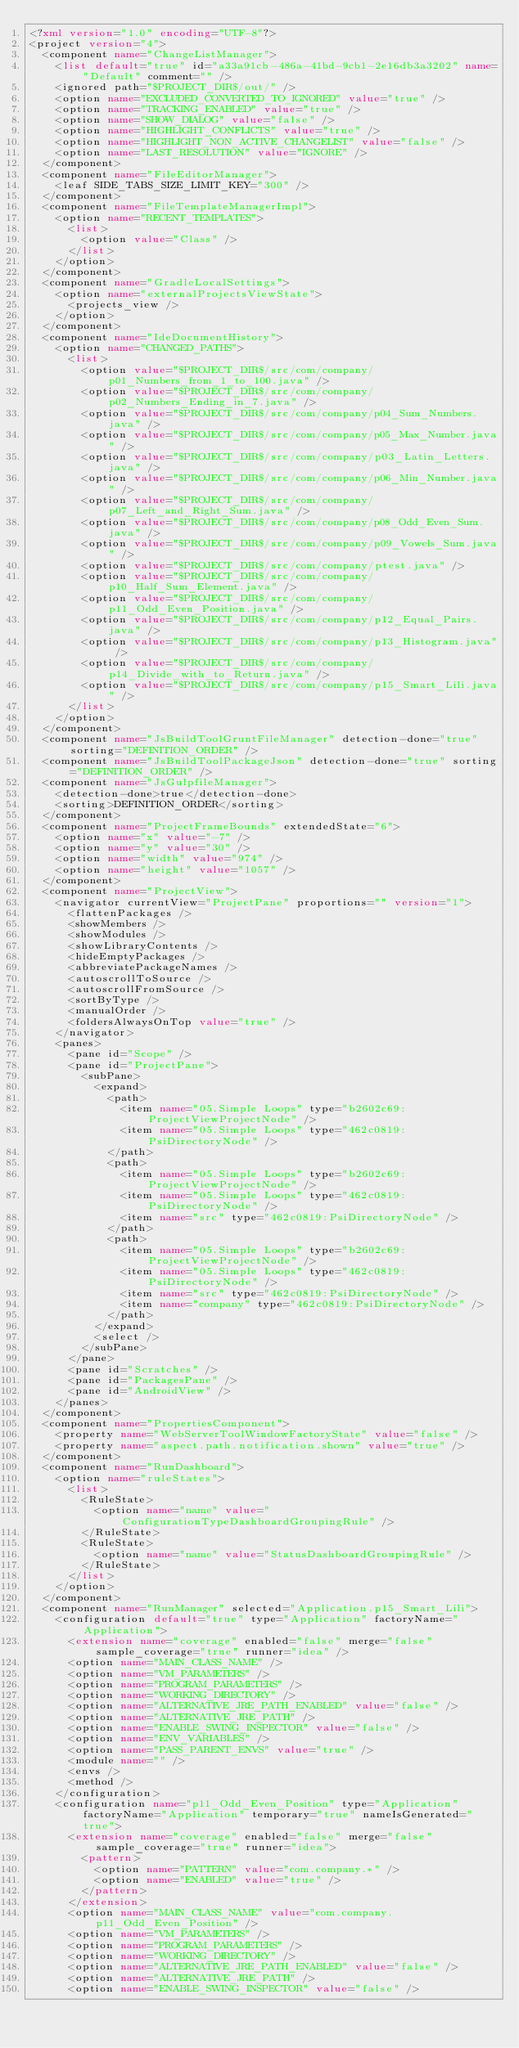<code> <loc_0><loc_0><loc_500><loc_500><_XML_><?xml version="1.0" encoding="UTF-8"?>
<project version="4">
  <component name="ChangeListManager">
    <list default="true" id="a33a91cb-486a-41bd-9cb1-2e16db3a3202" name="Default" comment="" />
    <ignored path="$PROJECT_DIR$/out/" />
    <option name="EXCLUDED_CONVERTED_TO_IGNORED" value="true" />
    <option name="TRACKING_ENABLED" value="true" />
    <option name="SHOW_DIALOG" value="false" />
    <option name="HIGHLIGHT_CONFLICTS" value="true" />
    <option name="HIGHLIGHT_NON_ACTIVE_CHANGELIST" value="false" />
    <option name="LAST_RESOLUTION" value="IGNORE" />
  </component>
  <component name="FileEditorManager">
    <leaf SIDE_TABS_SIZE_LIMIT_KEY="300" />
  </component>
  <component name="FileTemplateManagerImpl">
    <option name="RECENT_TEMPLATES">
      <list>
        <option value="Class" />
      </list>
    </option>
  </component>
  <component name="GradleLocalSettings">
    <option name="externalProjectsViewState">
      <projects_view />
    </option>
  </component>
  <component name="IdeDocumentHistory">
    <option name="CHANGED_PATHS">
      <list>
        <option value="$PROJECT_DIR$/src/com/company/p01_Numbers_from_1_to_100.java" />
        <option value="$PROJECT_DIR$/src/com/company/p02_Numbers_Ending_in_7.java" />
        <option value="$PROJECT_DIR$/src/com/company/p04_Sum_Numbers.java" />
        <option value="$PROJECT_DIR$/src/com/company/p05_Max_Number.java" />
        <option value="$PROJECT_DIR$/src/com/company/p03_Latin_Letters.java" />
        <option value="$PROJECT_DIR$/src/com/company/p06_Min_Number.java" />
        <option value="$PROJECT_DIR$/src/com/company/p07_Left_and_Right_Sum.java" />
        <option value="$PROJECT_DIR$/src/com/company/p08_Odd_Even_Sum.java" />
        <option value="$PROJECT_DIR$/src/com/company/p09_Vowels_Sum.java" />
        <option value="$PROJECT_DIR$/src/com/company/ptest.java" />
        <option value="$PROJECT_DIR$/src/com/company/p10_Half_Sum_Element.java" />
        <option value="$PROJECT_DIR$/src/com/company/p11_Odd_Even_Position.java" />
        <option value="$PROJECT_DIR$/src/com/company/p12_Equal_Pairs.java" />
        <option value="$PROJECT_DIR$/src/com/company/p13_Histogram.java" />
        <option value="$PROJECT_DIR$/src/com/company/p14_Divide_with_to_Return.java" />
        <option value="$PROJECT_DIR$/src/com/company/p15_Smart_Lili.java" />
      </list>
    </option>
  </component>
  <component name="JsBuildToolGruntFileManager" detection-done="true" sorting="DEFINITION_ORDER" />
  <component name="JsBuildToolPackageJson" detection-done="true" sorting="DEFINITION_ORDER" />
  <component name="JsGulpfileManager">
    <detection-done>true</detection-done>
    <sorting>DEFINITION_ORDER</sorting>
  </component>
  <component name="ProjectFrameBounds" extendedState="6">
    <option name="x" value="-7" />
    <option name="y" value="30" />
    <option name="width" value="974" />
    <option name="height" value="1057" />
  </component>
  <component name="ProjectView">
    <navigator currentView="ProjectPane" proportions="" version="1">
      <flattenPackages />
      <showMembers />
      <showModules />
      <showLibraryContents />
      <hideEmptyPackages />
      <abbreviatePackageNames />
      <autoscrollToSource />
      <autoscrollFromSource />
      <sortByType />
      <manualOrder />
      <foldersAlwaysOnTop value="true" />
    </navigator>
    <panes>
      <pane id="Scope" />
      <pane id="ProjectPane">
        <subPane>
          <expand>
            <path>
              <item name="05.Simple Loops" type="b2602c69:ProjectViewProjectNode" />
              <item name="05.Simple Loops" type="462c0819:PsiDirectoryNode" />
            </path>
            <path>
              <item name="05.Simple Loops" type="b2602c69:ProjectViewProjectNode" />
              <item name="05.Simple Loops" type="462c0819:PsiDirectoryNode" />
              <item name="src" type="462c0819:PsiDirectoryNode" />
            </path>
            <path>
              <item name="05.Simple Loops" type="b2602c69:ProjectViewProjectNode" />
              <item name="05.Simple Loops" type="462c0819:PsiDirectoryNode" />
              <item name="src" type="462c0819:PsiDirectoryNode" />
              <item name="company" type="462c0819:PsiDirectoryNode" />
            </path>
          </expand>
          <select />
        </subPane>
      </pane>
      <pane id="Scratches" />
      <pane id="PackagesPane" />
      <pane id="AndroidView" />
    </panes>
  </component>
  <component name="PropertiesComponent">
    <property name="WebServerToolWindowFactoryState" value="false" />
    <property name="aspect.path.notification.shown" value="true" />
  </component>
  <component name="RunDashboard">
    <option name="ruleStates">
      <list>
        <RuleState>
          <option name="name" value="ConfigurationTypeDashboardGroupingRule" />
        </RuleState>
        <RuleState>
          <option name="name" value="StatusDashboardGroupingRule" />
        </RuleState>
      </list>
    </option>
  </component>
  <component name="RunManager" selected="Application.p15_Smart_Lili">
    <configuration default="true" type="Application" factoryName="Application">
      <extension name="coverage" enabled="false" merge="false" sample_coverage="true" runner="idea" />
      <option name="MAIN_CLASS_NAME" />
      <option name="VM_PARAMETERS" />
      <option name="PROGRAM_PARAMETERS" />
      <option name="WORKING_DIRECTORY" />
      <option name="ALTERNATIVE_JRE_PATH_ENABLED" value="false" />
      <option name="ALTERNATIVE_JRE_PATH" />
      <option name="ENABLE_SWING_INSPECTOR" value="false" />
      <option name="ENV_VARIABLES" />
      <option name="PASS_PARENT_ENVS" value="true" />
      <module name="" />
      <envs />
      <method />
    </configuration>
    <configuration name="p11_Odd_Even_Position" type="Application" factoryName="Application" temporary="true" nameIsGenerated="true">
      <extension name="coverage" enabled="false" merge="false" sample_coverage="true" runner="idea">
        <pattern>
          <option name="PATTERN" value="com.company.*" />
          <option name="ENABLED" value="true" />
        </pattern>
      </extension>
      <option name="MAIN_CLASS_NAME" value="com.company.p11_Odd_Even_Position" />
      <option name="VM_PARAMETERS" />
      <option name="PROGRAM_PARAMETERS" />
      <option name="WORKING_DIRECTORY" />
      <option name="ALTERNATIVE_JRE_PATH_ENABLED" value="false" />
      <option name="ALTERNATIVE_JRE_PATH" />
      <option name="ENABLE_SWING_INSPECTOR" value="false" /></code> 